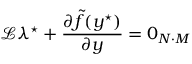Convert formula to latex. <formula><loc_0><loc_0><loc_500><loc_500>\mathcal { L } \lambda ^ { ^ { * } } + \frac { \partial \tilde { f } ( y ^ { ^ { * } } ) } { \partial y } = 0 _ { N \cdot M }</formula> 